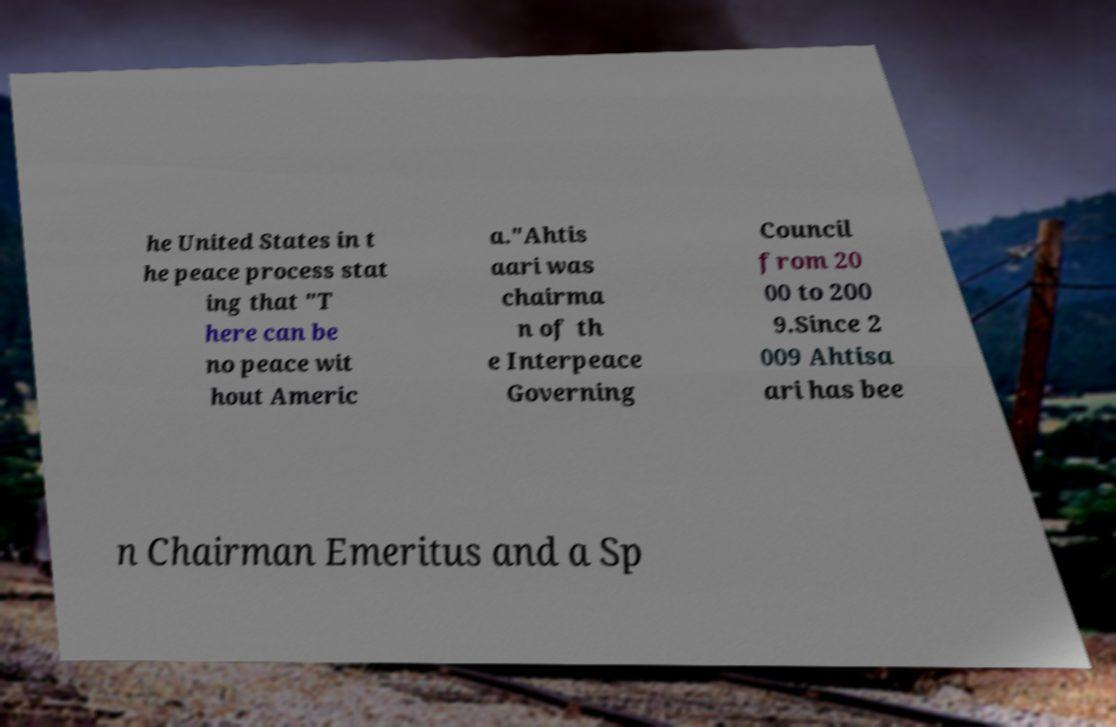Can you read and provide the text displayed in the image?This photo seems to have some interesting text. Can you extract and type it out for me? he United States in t he peace process stat ing that "T here can be no peace wit hout Americ a."Ahtis aari was chairma n of th e Interpeace Governing Council from 20 00 to 200 9.Since 2 009 Ahtisa ari has bee n Chairman Emeritus and a Sp 